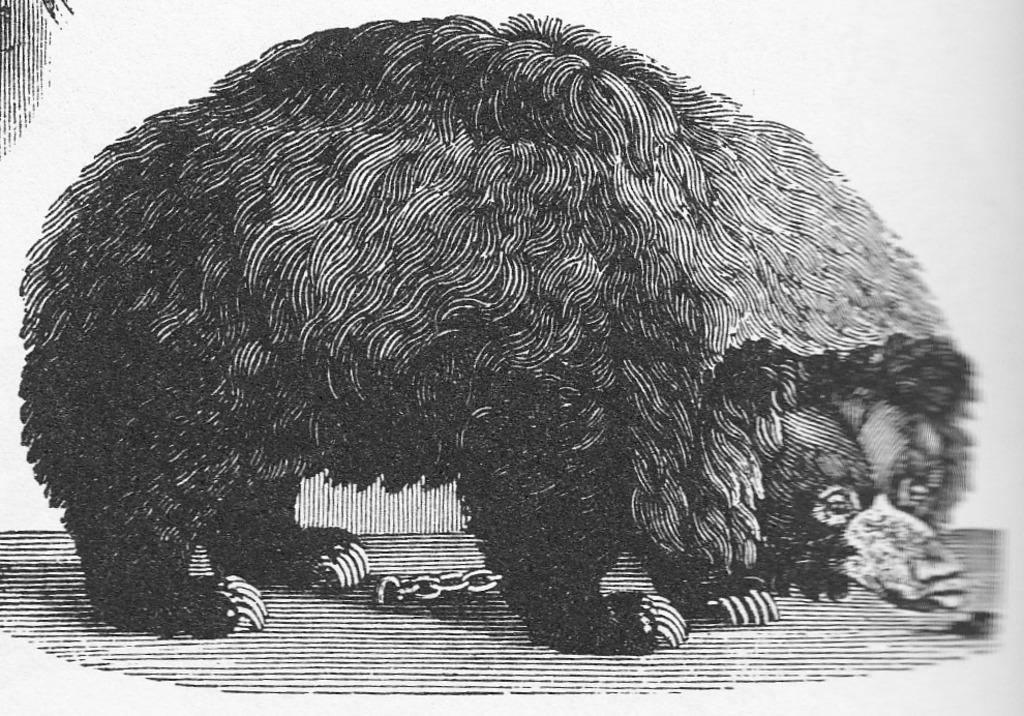What is depicted on the poster in the image? There is a poster of an animal in the image. What color are the lines on the poster? The lines on the poster are black. What color is the background of the image? The background of the image is white. What type of beetle can be seen playing a game on the poster? There is no beetle or game present on the poster; it features an animal with black lines on a white background. What is the animal eating for breakfast on the poster? There is no indication of the animal eating breakfast on the poster. 